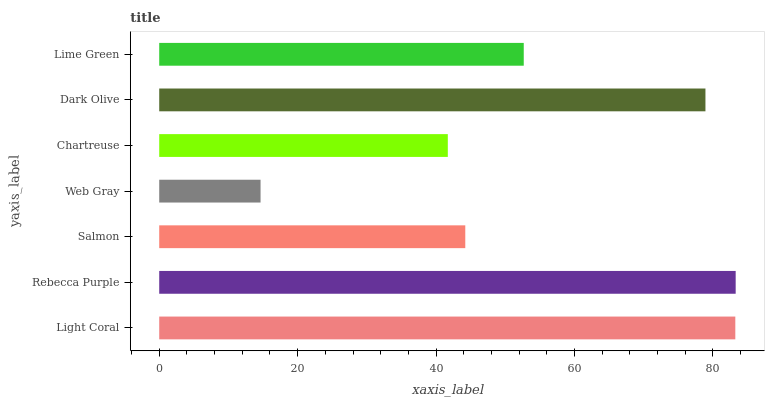Is Web Gray the minimum?
Answer yes or no. Yes. Is Rebecca Purple the maximum?
Answer yes or no. Yes. Is Salmon the minimum?
Answer yes or no. No. Is Salmon the maximum?
Answer yes or no. No. Is Rebecca Purple greater than Salmon?
Answer yes or no. Yes. Is Salmon less than Rebecca Purple?
Answer yes or no. Yes. Is Salmon greater than Rebecca Purple?
Answer yes or no. No. Is Rebecca Purple less than Salmon?
Answer yes or no. No. Is Lime Green the high median?
Answer yes or no. Yes. Is Lime Green the low median?
Answer yes or no. Yes. Is Chartreuse the high median?
Answer yes or no. No. Is Light Coral the low median?
Answer yes or no. No. 